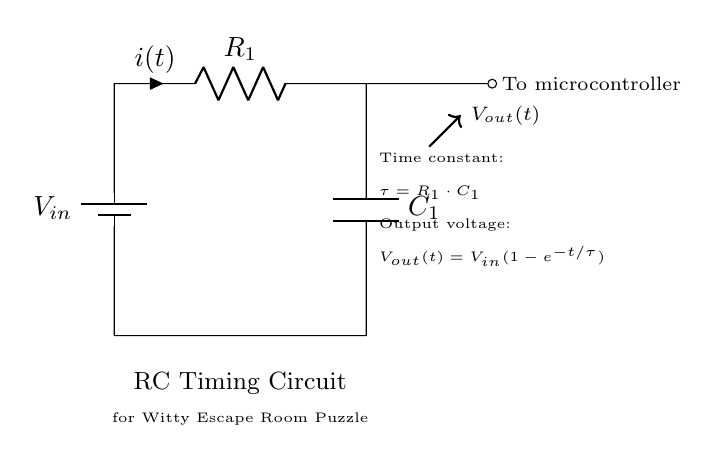What is the type of circuit shown? The circuit is an RC timing circuit, which consists of a resistor and a capacitor. This can be identified by the presence of both a resistor (R) and a capacitor (C) in a configuration that allows for timing or delay functions.
Answer: RC timing circuit What components are present in this circuit? The components present are a resistor and a capacitor connected to a battery. The resistor is labelled R1 and the capacitor is labelled C1. This is visually clear from the diagram where these elements are distinctly marked.
Answer: Resistor and Capacitor What is the role of the microcontroller in this circuit? The microcontroller receives the output voltage from the RC circuit, which is used for timing or control purposes. The connection to the microcontroller indicates that it will process the voltage signal, which is an essential function in escape room puzzles for controlling events based on time.
Answer: To process the output voltage What does the time constant τ represent in this circuit? The time constant τ is represented by the formula τ = R1 · C1 and indicates how quickly the capacitor charges or discharges through the resistor. This means the time constant directly influences the rate of voltage change across the capacitor, determining how long it takes to reach a certain voltage level.
Answer: R1 times C1 What is the output voltage formula for this circuit? The output voltage formula is Vout(t) = Vin(1 - e^(-t/τ)). This equation shows how the output voltage changes over time as the capacitor charges, emphasizing the exponential nature of this process, which is a characteristic feature of RC circuits.
Answer: Vout(t) equals Vin times one minus e to the power of negative t over τ How does the resistor affect the circuit's timing? The resistor affects the timing by determining the rate at which the capacitor charges or discharges. A larger resistance will lead to a longer time constant τ, resulting in slower voltage changes. Conversely, a smaller resistance decreases τ, making the response quicker. This relationship showcases the importance of resistance in time-sensitive applications, like in an escape room scenario.
Answer: By controlling the charge/discharge rate What happens to the output voltage as time approaches infinity? As time approaches infinity, the exponential term in the output voltage formula (e^(-t/τ)) approaches zero, meaning that Vout will asymptotically approach Vin. This behavior is characteristic of RC circuits, indicating that the capacitor becomes fully charged and no further current flows through the resistor after a long duration.
Answer: Approaches Vin 